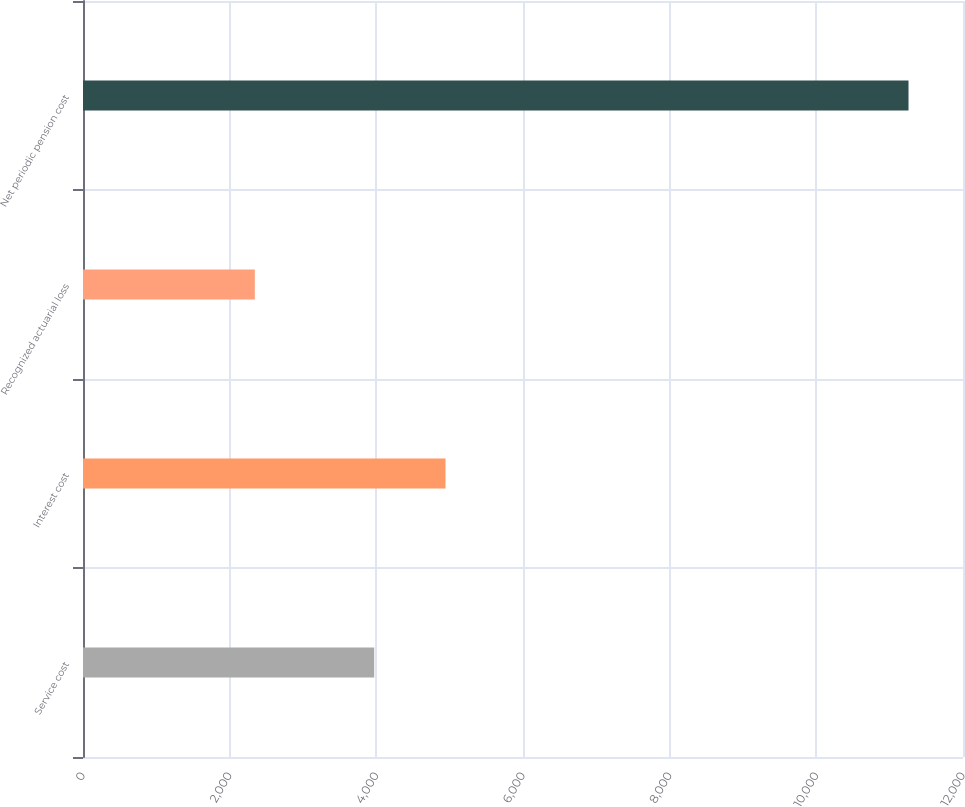Convert chart to OTSL. <chart><loc_0><loc_0><loc_500><loc_500><bar_chart><fcel>Service cost<fcel>Interest cost<fcel>Recognized actuarial loss<fcel>Net periodic pension cost<nl><fcel>3971<fcel>4943<fcel>2343<fcel>11257<nl></chart> 